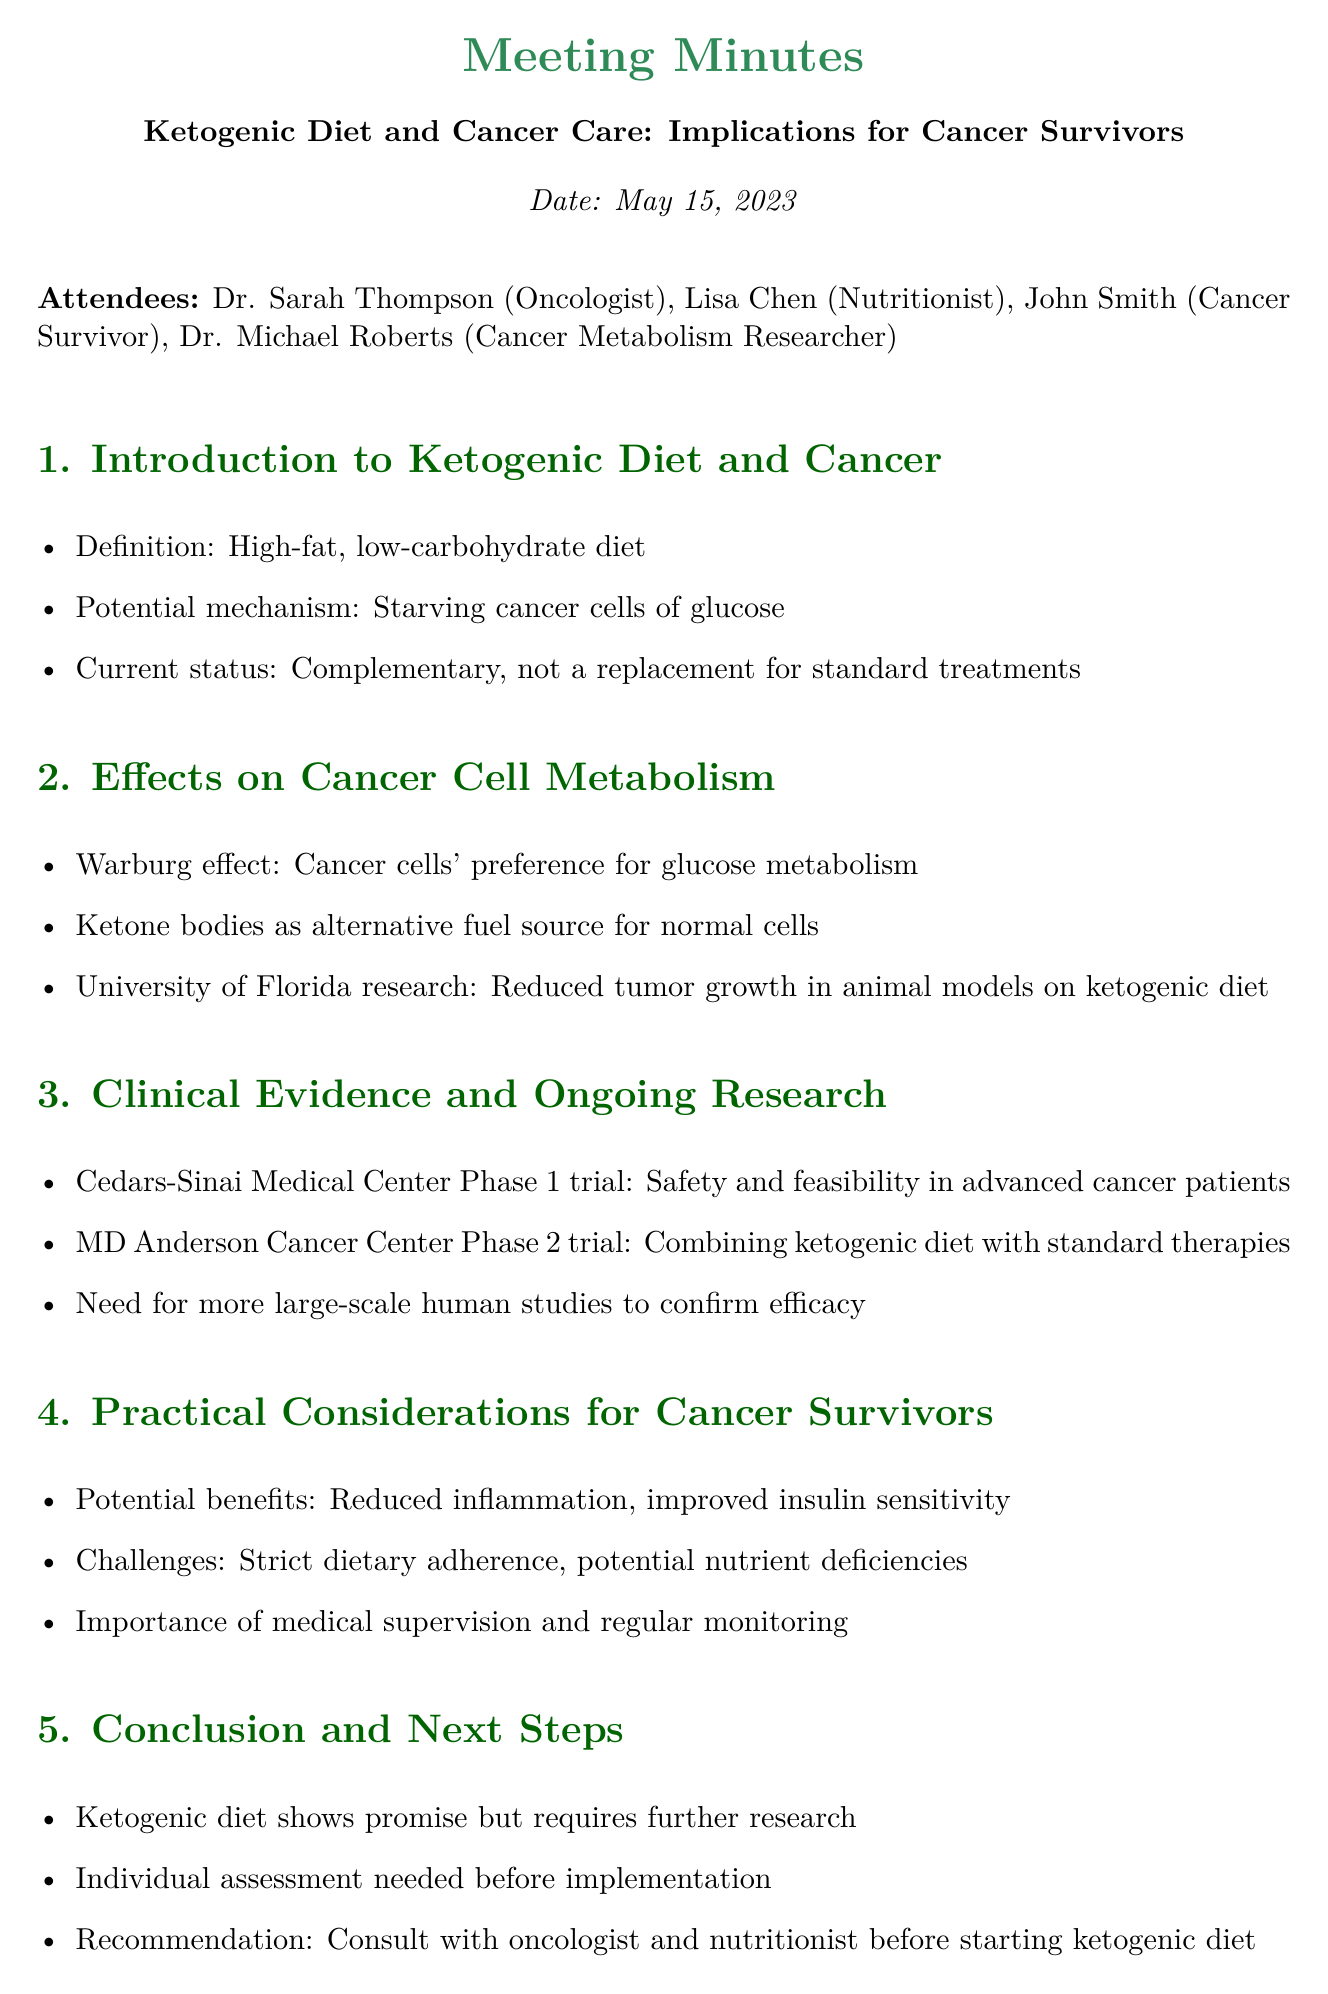What is the date of the meeting? The date of the meeting is explicitly stated in the document.
Answer: May 15, 2023 Who attended the meeting as a nutritionist? The document lists the attendees and identifies Lisa Chen as the nutritionist.
Answer: Lisa Chen What is the definition of the ketogenic diet mentioned? The document provides a clear definition of the ketogenic diet in the introduction section.
Answer: High-fat, low-carbohydrate diet What is one potential benefit of the ketogenic diet for cancer survivors? The section on practical considerations mentions the potential benefits of the ketogenic diet.
Answer: Reduced inflammation What type of cancer cell metabolism is referenced in relation to the ketogenic diet? The document refers to the "Warburg effect" related to cancer cell metabolism.
Answer: Warburg effect What phase trial is ongoing at MD Anderson Cancer Center? The document specifies the ongoing phase 2 trial at MD Anderson Cancer Center.
Answer: Phase 2 trial What is a challenge mentioned regarding the ketogenic diet? The document lists challenges that cancer survivors may face with the ketogenic diet.
Answer: Strict dietary adherence Is medical supervision important before starting the ketogenic diet? The conclusion section emphasizes the importance of medical supervision.
Answer: Yes 